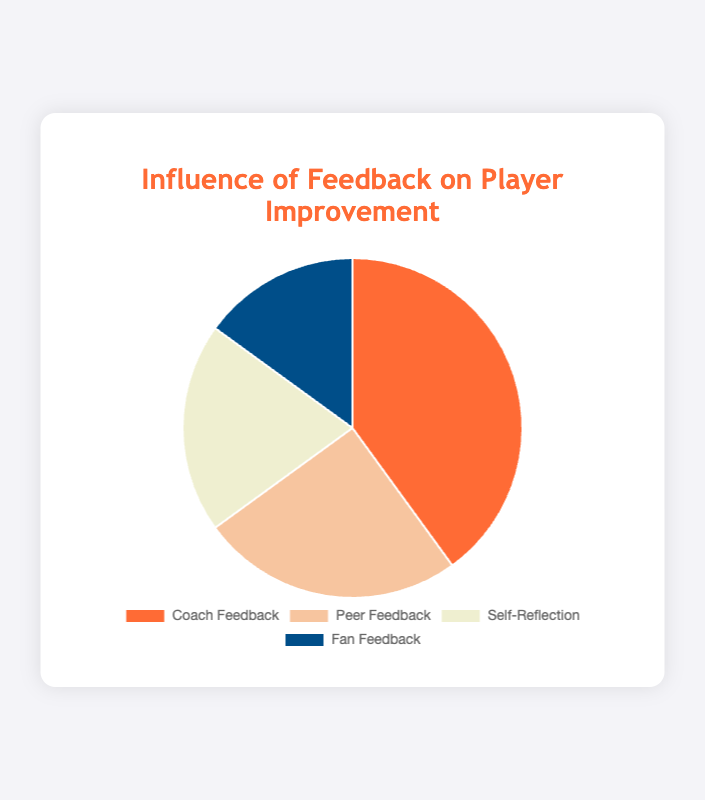Which type of feedback has the highest influence on player improvement? The pie chart shows that Coach Feedback occupies the largest segment.
Answer: Coach Feedback Which feedback type has the least influence on player improvement? The smallest segment in the pie chart is for Fan Feedback.
Answer: Fan Feedback What is the total influence percentage of Self-Reflection and Fan Feedback combined? Add the influence of Self-Reflection (20%) and Fan Feedback (15%). 20 + 15 = 35.
Answer: 35% Is Peer Feedback greater than the combined influence of Fan Feedback and Self-Reflection? Calculate the combined influence of Fan Feedback (15%) and Self-Reflection (20%), which is 15 + 20 = 35. Peer Feedback is 25%, which is less than 35.
Answer: No What is the difference in the influence percentage between Coach Feedback and Peer Feedback? Subtract the influence of Peer Feedback (25%) from the influence of Coach Feedback (40%). 40 - 25 = 15.
Answer: 15 How much more influential is Coach Feedback compared to Self-Reflection? Subtract the influence of Self-Reflection (20%) from Coach Feedback (40%). 40 - 20 = 20.
Answer: 20 Which feedback type is represented by the orange segment in the pie chart? The legend shows that the orange segment represents Fan Feedback.
Answer: Fan Feedback Rank the feedback types from highest to lowest influence. According to the chart: Coach Feedback (40%), Peer Feedback (25%), Self-Reflection (20%), Fan Feedback (15%).
Answer: Coach Feedback, Peer Feedback, Self-Reflection, Fan Feedback What is the average influence percentage across all feedback types? Add all the percentages: 40 + 25 + 20 + 15 = 100. Divide by the number of feedback types, 100/4 = 25.
Answer: 25 If the influence of Fan Feedback increased by 10%, how would this change its ranking relative to the other feedback types? Current Fan Feedback is 15%. Adding 10% makes it 25%, which equals Peer Feedback. Fan Feedback would rank equal to Peer Feedback, and only above Self-Reflection.
Answer: Equal to Peer Feedback, above Self-Reflection 